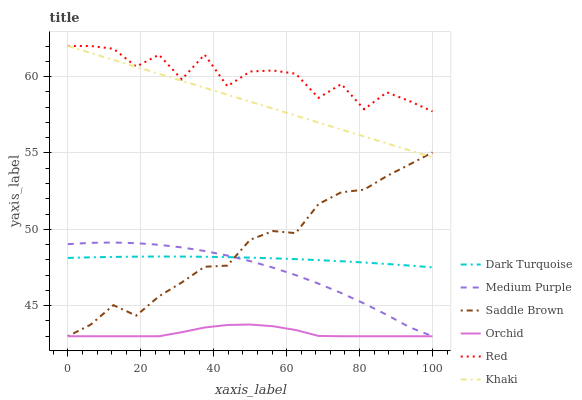Does Dark Turquoise have the minimum area under the curve?
Answer yes or no. No. Does Dark Turquoise have the maximum area under the curve?
Answer yes or no. No. Is Dark Turquoise the smoothest?
Answer yes or no. No. Is Dark Turquoise the roughest?
Answer yes or no. No. Does Dark Turquoise have the lowest value?
Answer yes or no. No. Does Dark Turquoise have the highest value?
Answer yes or no. No. Is Medium Purple less than Red?
Answer yes or no. Yes. Is Red greater than Medium Purple?
Answer yes or no. Yes. Does Medium Purple intersect Red?
Answer yes or no. No. 